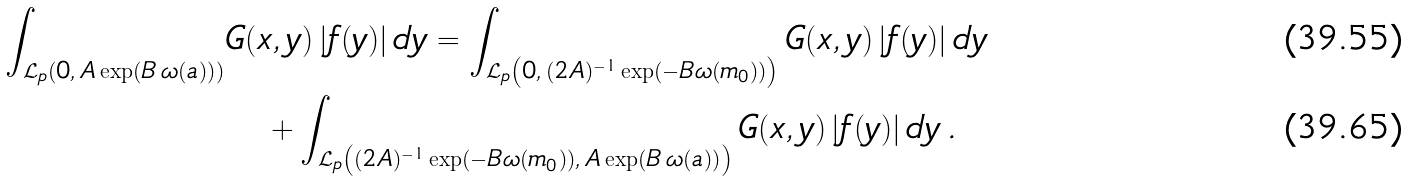<formula> <loc_0><loc_0><loc_500><loc_500>\int _ { \mathcal { L } _ { p } \left ( 0 , \, A \exp \left ( B \, \omega ( a ) \right ) \right ) } & G ( x , y ) \, | f ( y ) | \, d y = \int _ { \mathcal { L } _ { p } \left ( 0 , \, ( 2 A ) ^ { - 1 } \exp ( - B \omega ( m _ { 0 } ) ) \right ) } G ( x , y ) \, | f ( y ) | \, d y \\ & \quad + \int _ { \mathcal { L } _ { p } \left ( ( 2 A ) ^ { - 1 } \exp ( - B \omega ( m _ { 0 } ) ) , \, A \exp \left ( B \, \omega ( a ) \right ) \right ) } G ( x , y ) \, | f ( y ) | \, d y \, .</formula> 